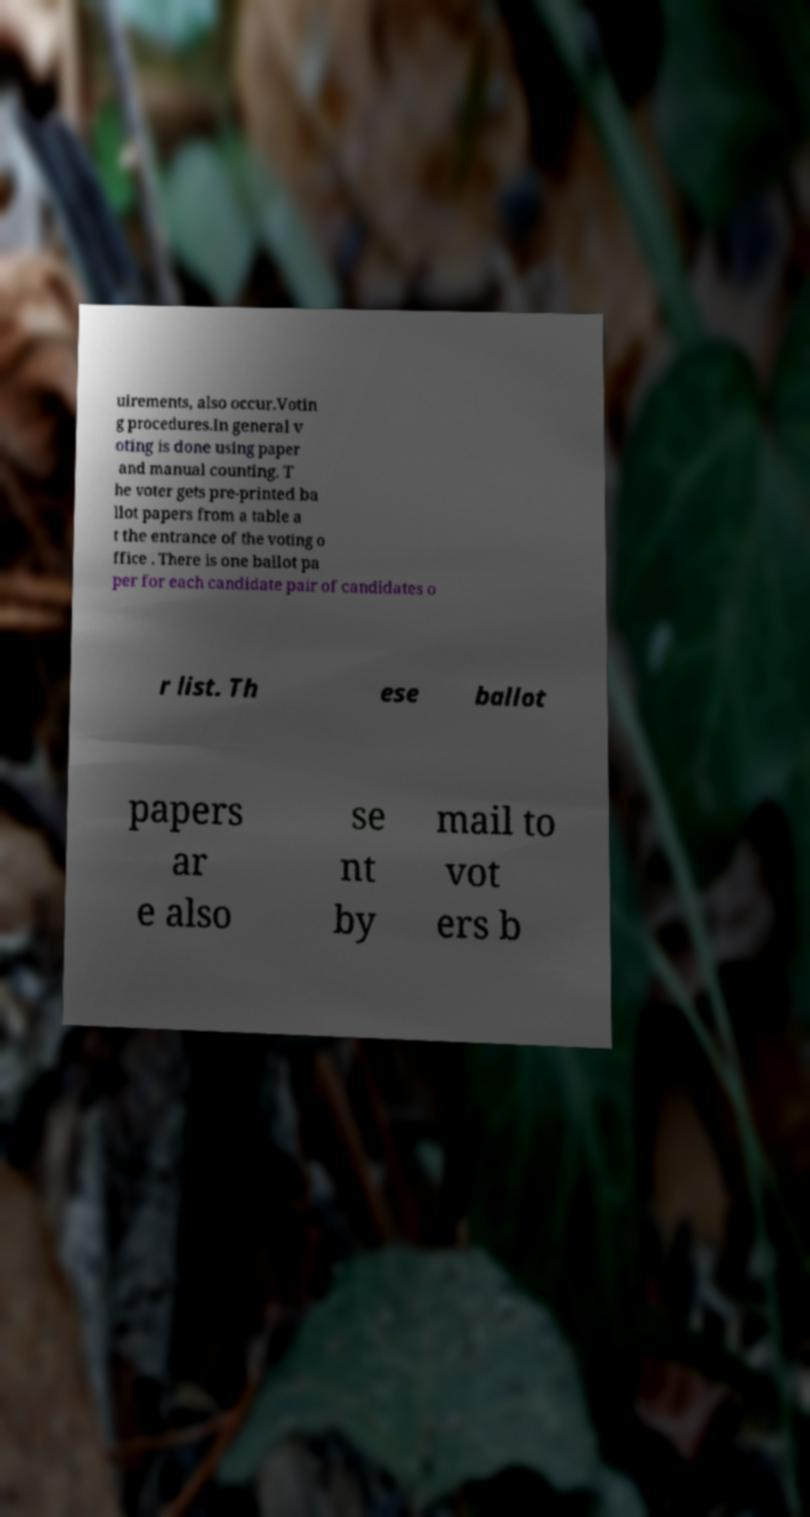Can you read and provide the text displayed in the image?This photo seems to have some interesting text. Can you extract and type it out for me? uirements, also occur.Votin g procedures.In general v oting is done using paper and manual counting. T he voter gets pre-printed ba llot papers from a table a t the entrance of the voting o ffice . There is one ballot pa per for each candidate pair of candidates o r list. Th ese ballot papers ar e also se nt by mail to vot ers b 